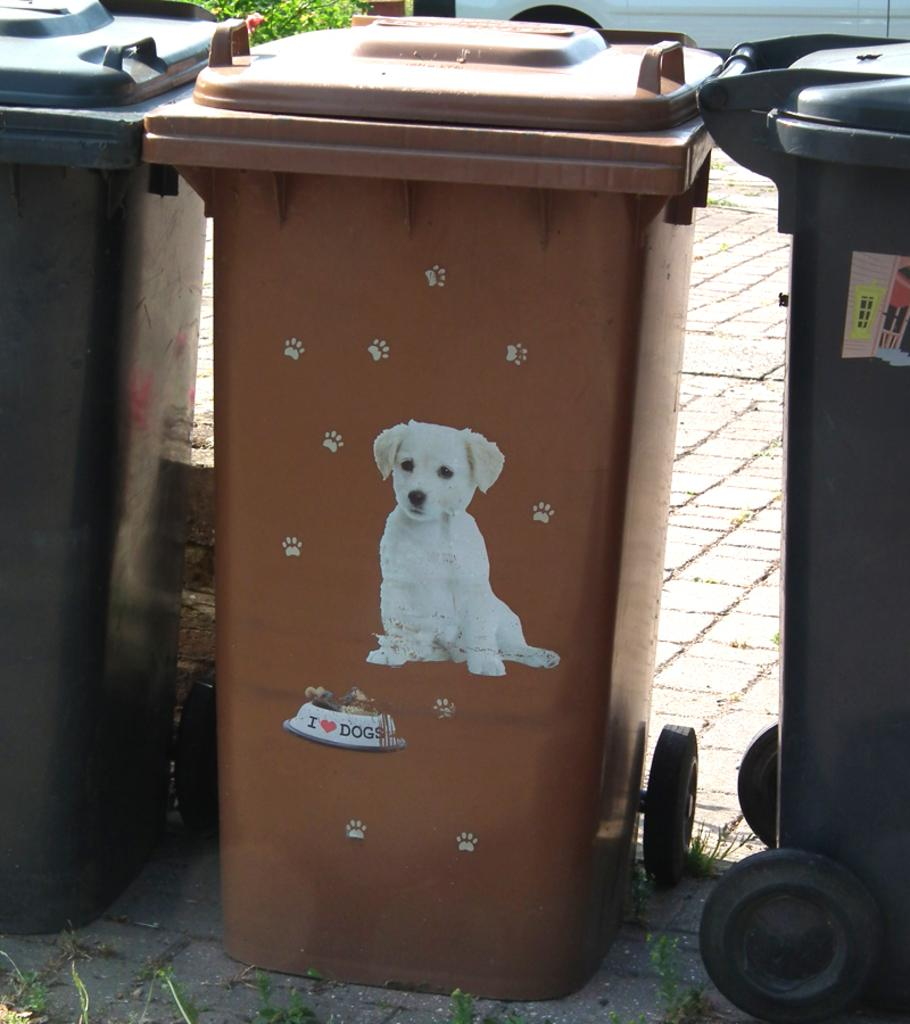<image>
Give a short and clear explanation of the subsequent image. A trash can wit ha picture of a puppy on it with the bould saying I heart dogs. 